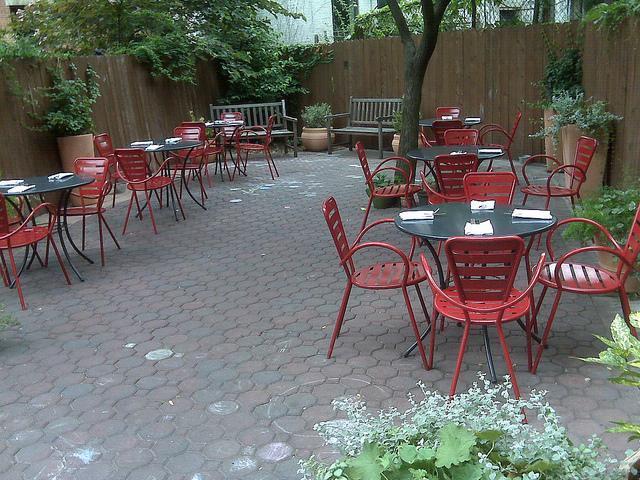How many tables are in the picture?
Give a very brief answer. 6. How many chairs can be seen?
Give a very brief answer. 8. How many potted plants are there?
Give a very brief answer. 7. How many benches are in the picture?
Give a very brief answer. 2. 